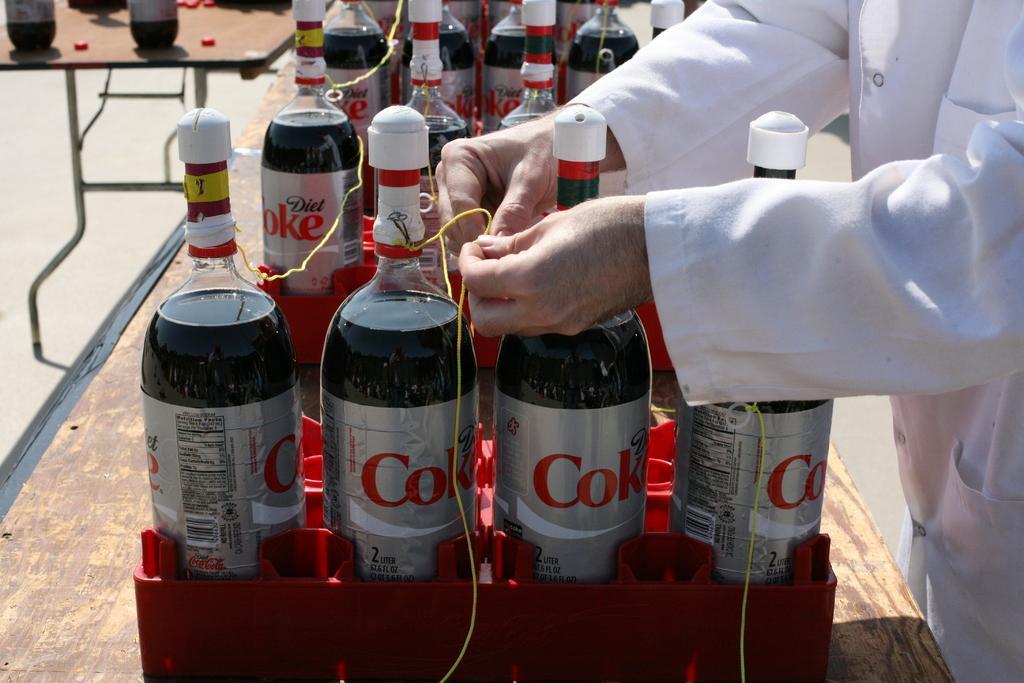Could you give a brief overview of what you see in this image? There are many bottles with labels are kept on a boxes. And there are small threads connecting between the bottles. A person wearing a white coat is tying the thread. 